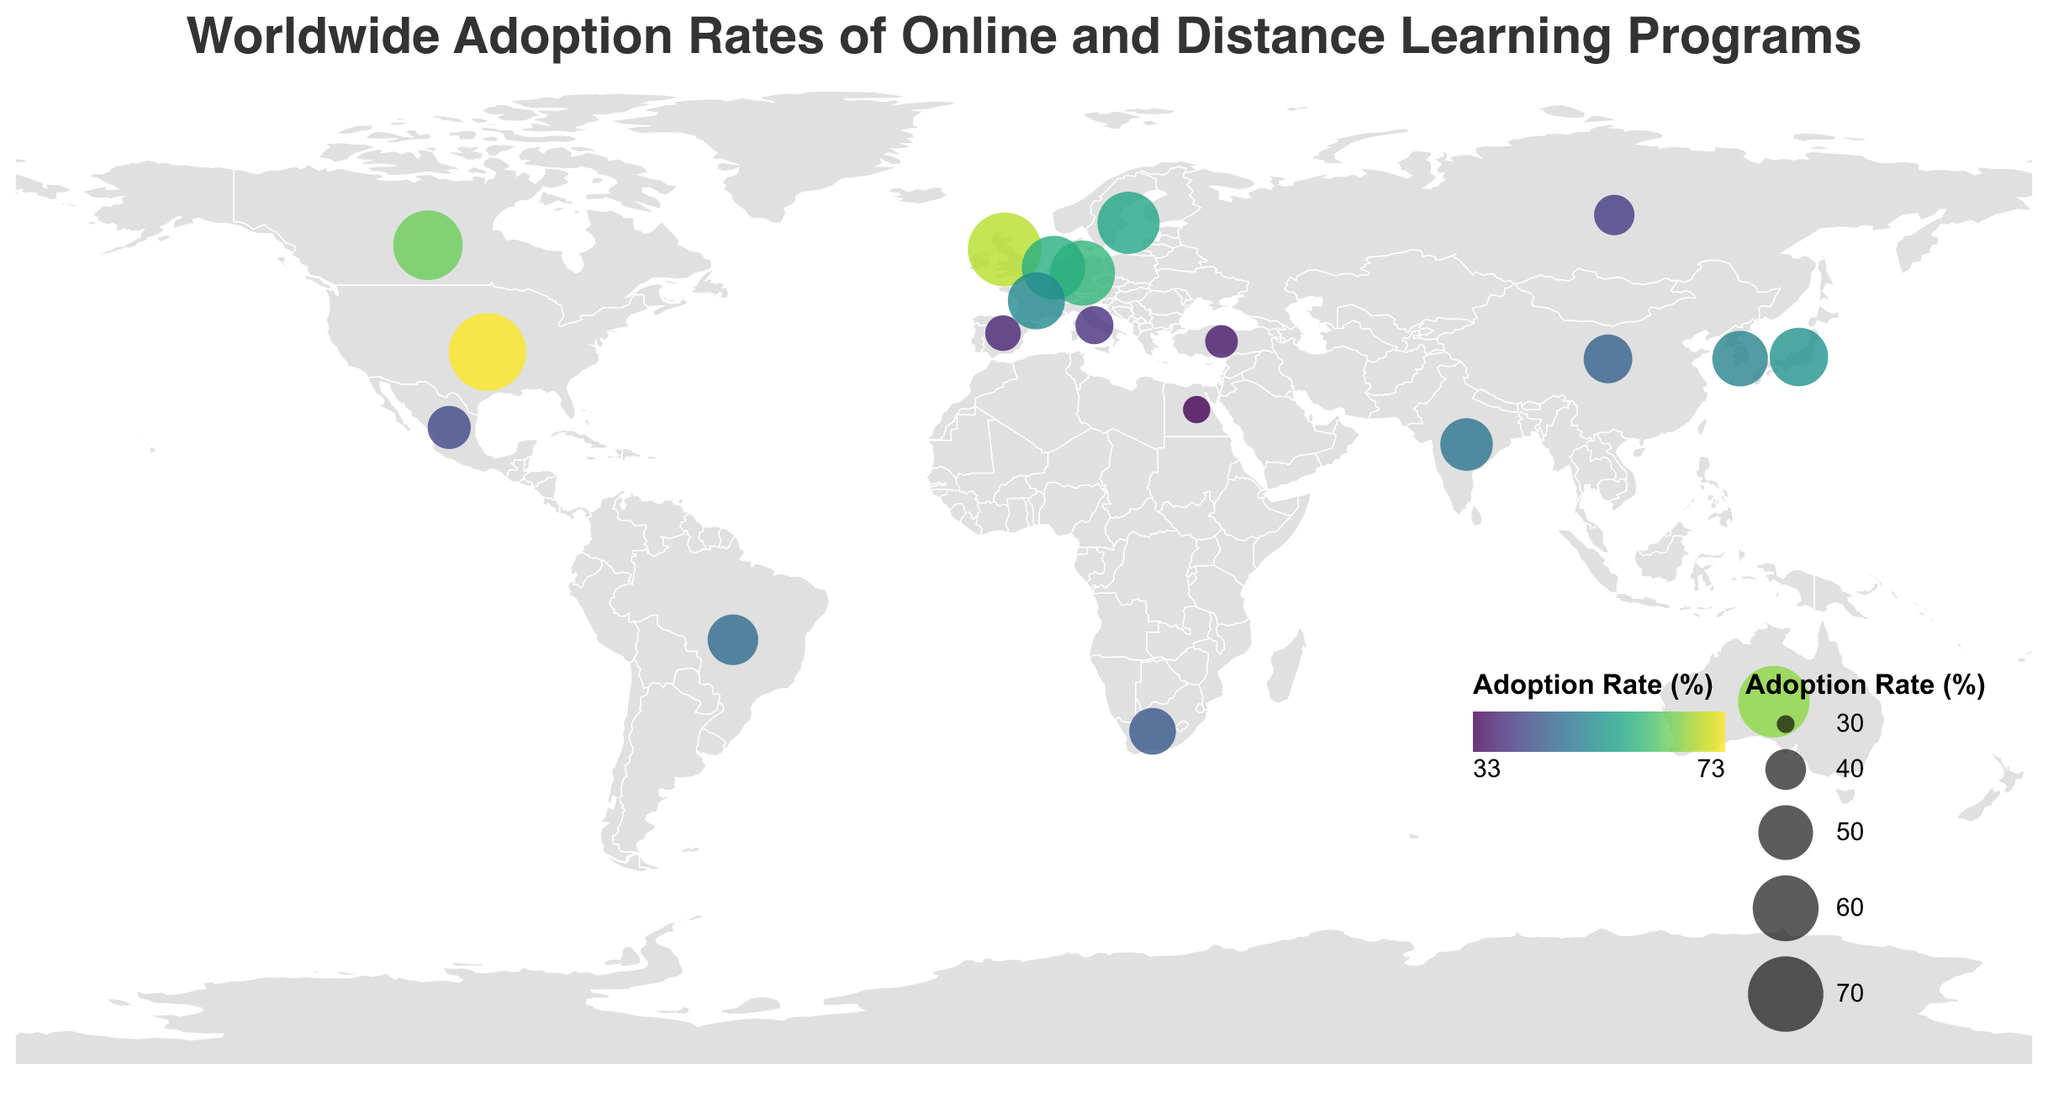What's the title of the figure? The title is usually displayed at the top of the figure in bold or larger font.
Answer: Worldwide Adoption Rates of Online and Distance Learning Programs Which country has the highest adoption rate? The largest circle in size and the corresponding tooltip will identify the country with the highest adoption rate.
Answer: United States How does the adoption rate in South Korea compare to that of France? Locate South Korea and France on the map, check the circle sizes/colors, and refer to the tooltips for exact rates.
Answer: South Korea is lower than France Which countries have an adoption rate above 60%? Look for circles with sizes/colors representing rates above 60% and check the relevant tooltips.
Answer: United States, United Kingdom, Australia, Canada, Germany What is the average adoption rate of the listed countries? Sum the adoption rates of all countries listed and divide by the total number of countries (20). Detailed calculations: 
(72.5 + 68.3 + 65.9 + 63.7 + 59.2 + 57.8 + 56.4 + 53.1 + 51.9 + 50.6 + 48.2 + 46.7 + 45.3 + 43.9 + 41.5 + 39.8 + 38.4 + 37.1 + 35.6 + 33.2) / 20 = 50.38
Answer: 50.38 Which region (continent) has the lowest overall adoption rates based on the countries listed? Group countries by continent, find the average adoption rate for each, and compare them. Africa: (South Africa, Egypt); Asia: (Japan, South Korea, India, China, Russia, Turkey); Europe: (United Kingdom, Germany, Netherlands, Sweden, France, Spain, Italy); North America: (United States, Canada, Mexico); South America: (Brazil).
Africa: (43.9 + 33.2) / 2 = 38.55.
Asia: (53.1 + 50.6 + 48.2 + 45.3 + 39.8 + 35.6) / 6 = 45.43.
Europe: (68.3 + 59.2 + 57.8 + 56.4 + 51.9 + 37.1 + 38.4) / 7 = 52.01.
North America: (72.5 + 63.7 + 41.5) / 3 = 59.23.
South America: 46.7.
Lowest overall: Africa.
Answer: Africa What is the median adoption rate of all countries listed? List the adoption rates in ascending order and find the middle value. If even, average the two middle numbers:
33.2, 35.6, 37.1, 38.4, 39.8, 41.5, 43.9, 45.3, 46.7, 48.2, 50.6, 51.9, 53.1, 56.4, 57.8, 59.2, 63.7, 65.9, 68.3, 72.5. 
Middle numbers: 48.2, 50.6. 
Median: (48.2 + 50.6) / 2 = 49.4.
Answer: 49.4 How many countries have an adoption rate between 45% and 55%? Look at circles with colors/sizes representing this range and count them. Check tooltips for exact figures.
Answer: 6 